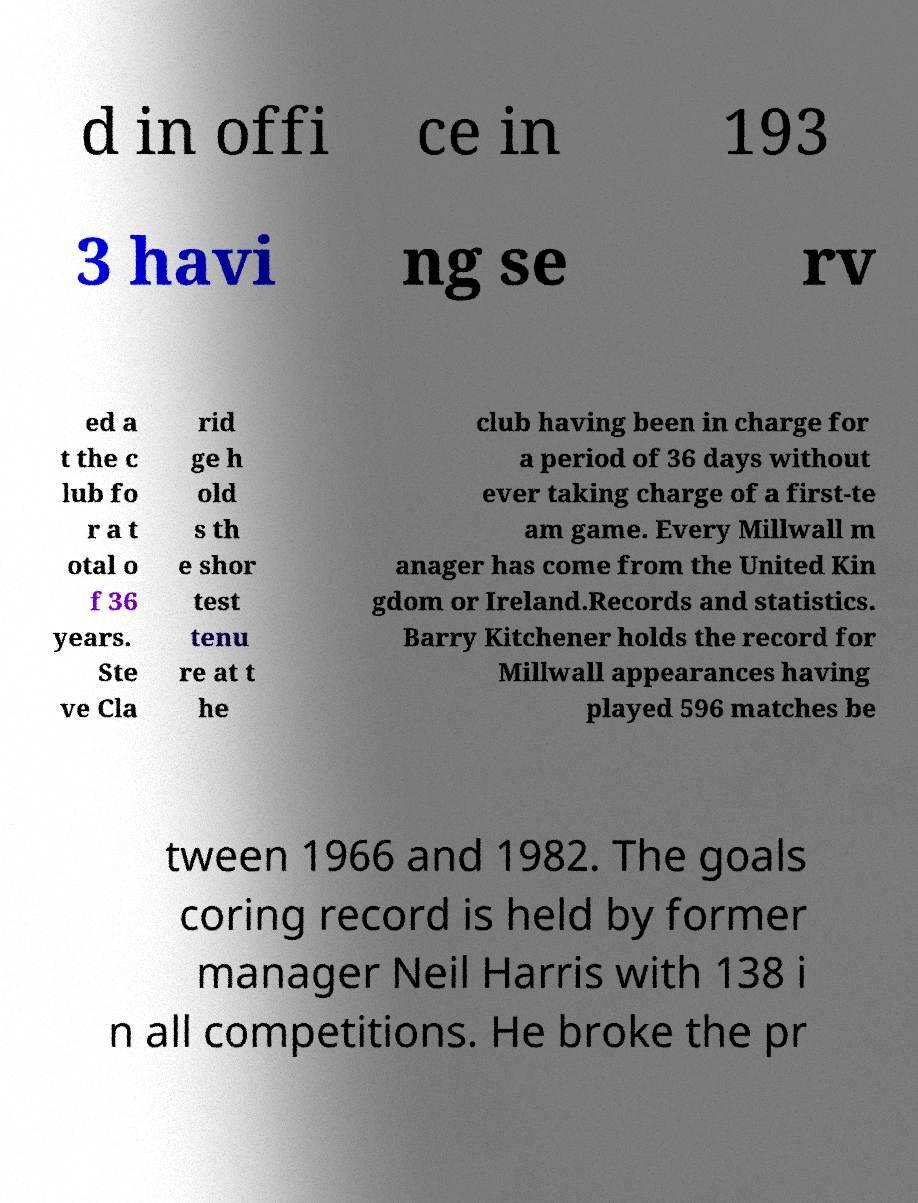Can you accurately transcribe the text from the provided image for me? d in offi ce in 193 3 havi ng se rv ed a t the c lub fo r a t otal o f 36 years. Ste ve Cla rid ge h old s th e shor test tenu re at t he club having been in charge for a period of 36 days without ever taking charge of a first-te am game. Every Millwall m anager has come from the United Kin gdom or Ireland.Records and statistics. Barry Kitchener holds the record for Millwall appearances having played 596 matches be tween 1966 and 1982. The goals coring record is held by former manager Neil Harris with 138 i n all competitions. He broke the pr 